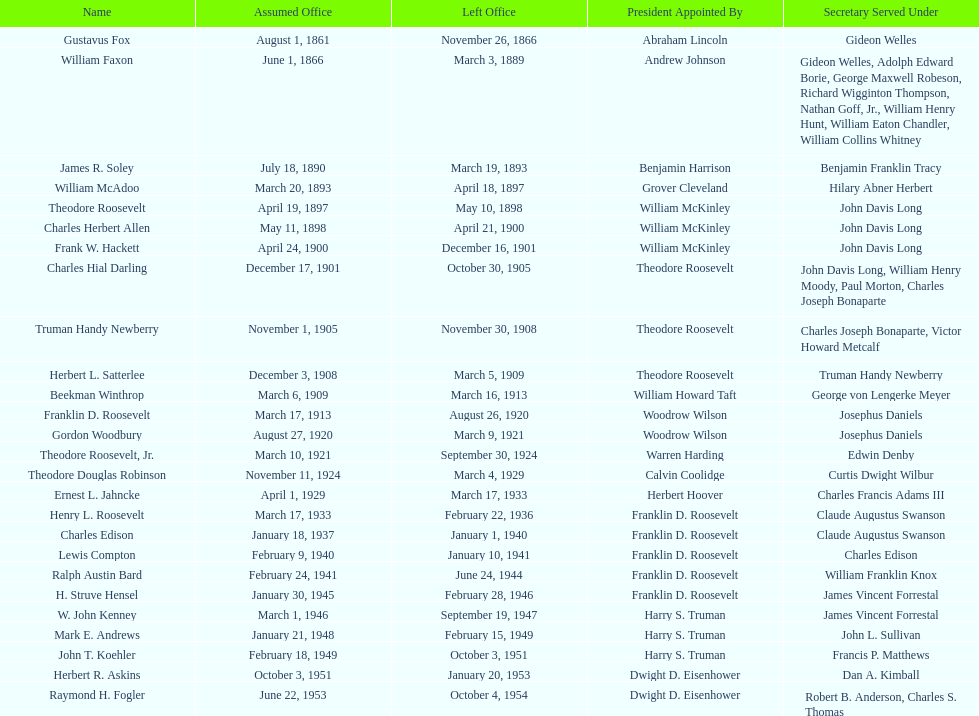What are the entire names? Gustavus Fox, William Faxon, James R. Soley, William McAdoo, Theodore Roosevelt, Charles Herbert Allen, Frank W. Hackett, Charles Hial Darling, Truman Handy Newberry, Herbert L. Satterlee, Beekman Winthrop, Franklin D. Roosevelt, Gordon Woodbury, Theodore Roosevelt, Jr., Theodore Douglas Robinson, Ernest L. Jahncke, Henry L. Roosevelt, Charles Edison, Lewis Compton, Ralph Austin Bard, H. Struve Hensel, W. John Kenney, Mark E. Andrews, John T. Koehler, Herbert R. Askins, Raymond H. Fogler. When was their time in office over? November 26, 1866, March 3, 1889, March 19, 1893, April 18, 1897, May 10, 1898, April 21, 1900, December 16, 1901, October 30, 1905, November 30, 1908, March 5, 1909, March 16, 1913, August 26, 1920, March 9, 1921, September 30, 1924, March 4, 1929, March 17, 1933, February 22, 1936, January 1, 1940, January 10, 1941, June 24, 1944, February 28, 1946, September 19, 1947, February 15, 1949, October 3, 1951, January 20, 1953, October 4, 1954. Furthermore, when did raymond h. fogler exit? October 4, 1954. 